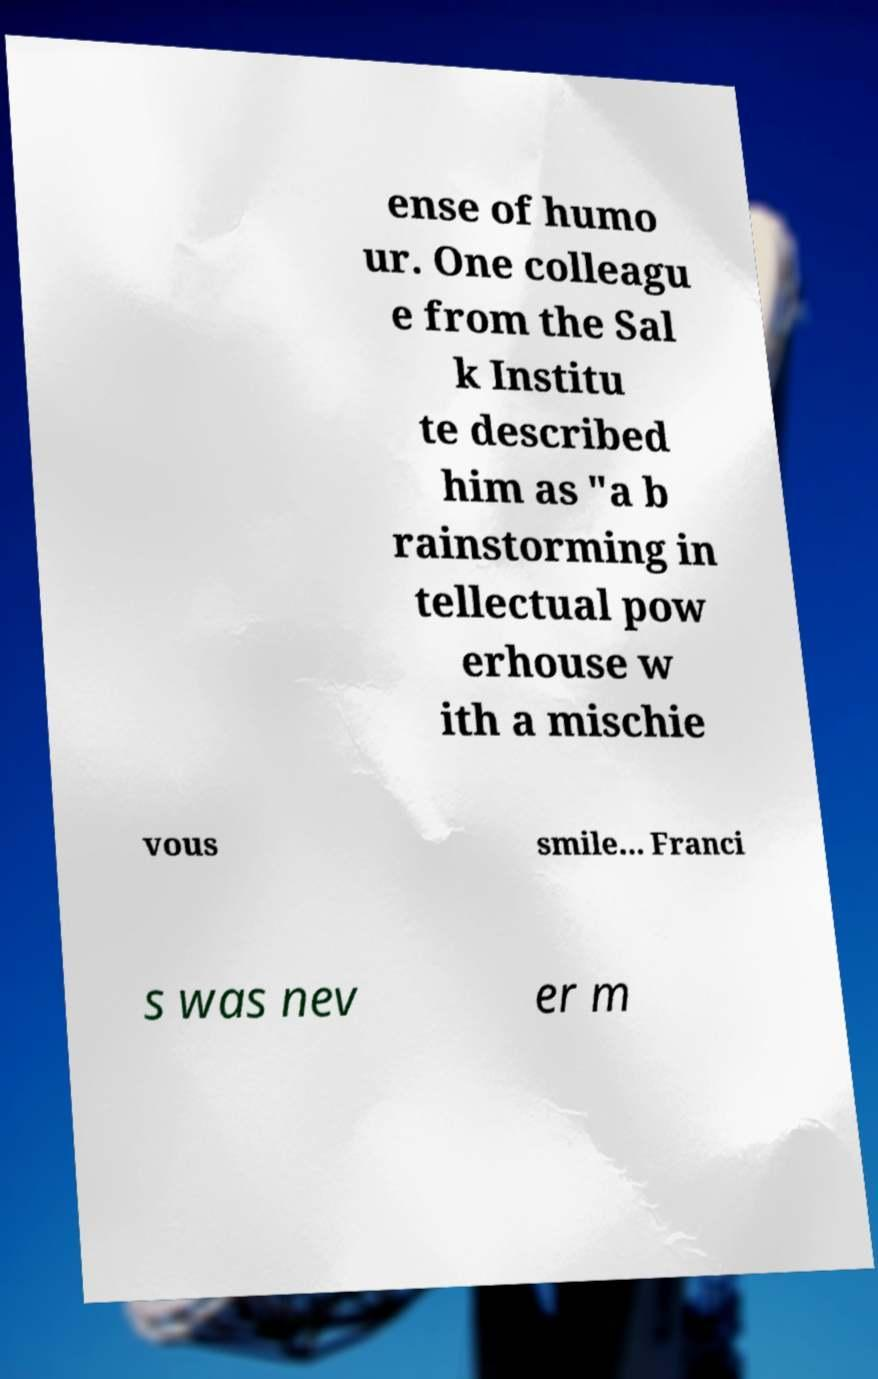Can you accurately transcribe the text from the provided image for me? ense of humo ur. One colleagu e from the Sal k Institu te described him as "a b rainstorming in tellectual pow erhouse w ith a mischie vous smile... Franci s was nev er m 